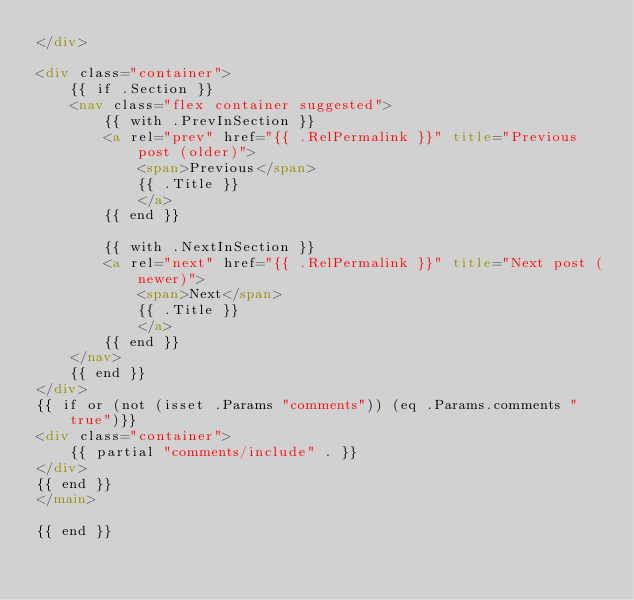<code> <loc_0><loc_0><loc_500><loc_500><_HTML_></div>

<div class="container">
    {{ if .Section }}
    <nav class="flex container suggested">
        {{ with .PrevInSection }}
        <a rel="prev" href="{{ .RelPermalink }}" title="Previous post (older)">
            <span>Previous</span>
            {{ .Title }}
            </a>
        {{ end }}
        
        {{ with .NextInSection }}
        <a rel="next" href="{{ .RelPermalink }}" title="Next post (newer)">
            <span>Next</span>
            {{ .Title }}
            </a> 
        {{ end }}
    </nav>
    {{ end }}
</div>
{{ if or (not (isset .Params "comments")) (eq .Params.comments "true")}} 
<div class="container">
    {{ partial "comments/include" . }}
</div>
{{ end }}
</main>

{{ end }}
</code> 